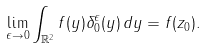Convert formula to latex. <formula><loc_0><loc_0><loc_500><loc_500>\lim _ { \epsilon \rightarrow 0 } \int _ { \mathbb { R } ^ { 2 } } f ( y ) \delta ^ { \epsilon } _ { 0 } ( y ) \, d y = f ( z _ { 0 } ) .</formula> 